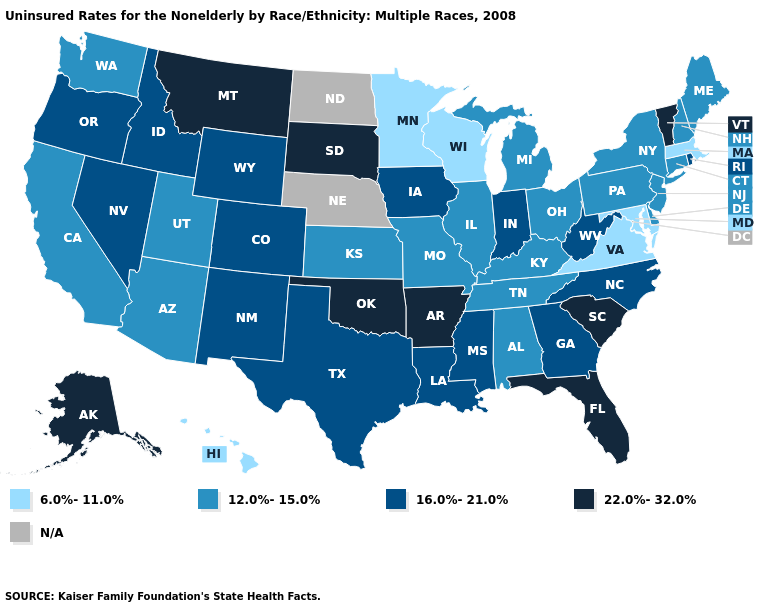What is the highest value in the USA?
Answer briefly. 22.0%-32.0%. Name the states that have a value in the range 6.0%-11.0%?
Give a very brief answer. Hawaii, Maryland, Massachusetts, Minnesota, Virginia, Wisconsin. Does Delaware have the lowest value in the South?
Be succinct. No. What is the value of Hawaii?
Quick response, please. 6.0%-11.0%. Does Pennsylvania have the highest value in the Northeast?
Concise answer only. No. What is the highest value in the USA?
Answer briefly. 22.0%-32.0%. What is the value of Alabama?
Short answer required. 12.0%-15.0%. What is the value of Maine?
Short answer required. 12.0%-15.0%. Name the states that have a value in the range 12.0%-15.0%?
Be succinct. Alabama, Arizona, California, Connecticut, Delaware, Illinois, Kansas, Kentucky, Maine, Michigan, Missouri, New Hampshire, New Jersey, New York, Ohio, Pennsylvania, Tennessee, Utah, Washington. What is the highest value in states that border Connecticut?
Quick response, please. 16.0%-21.0%. Name the states that have a value in the range 12.0%-15.0%?
Answer briefly. Alabama, Arizona, California, Connecticut, Delaware, Illinois, Kansas, Kentucky, Maine, Michigan, Missouri, New Hampshire, New Jersey, New York, Ohio, Pennsylvania, Tennessee, Utah, Washington. Among the states that border Massachusetts , does New Hampshire have the lowest value?
Write a very short answer. Yes. Does the map have missing data?
Quick response, please. Yes. What is the lowest value in the MidWest?
Answer briefly. 6.0%-11.0%. 